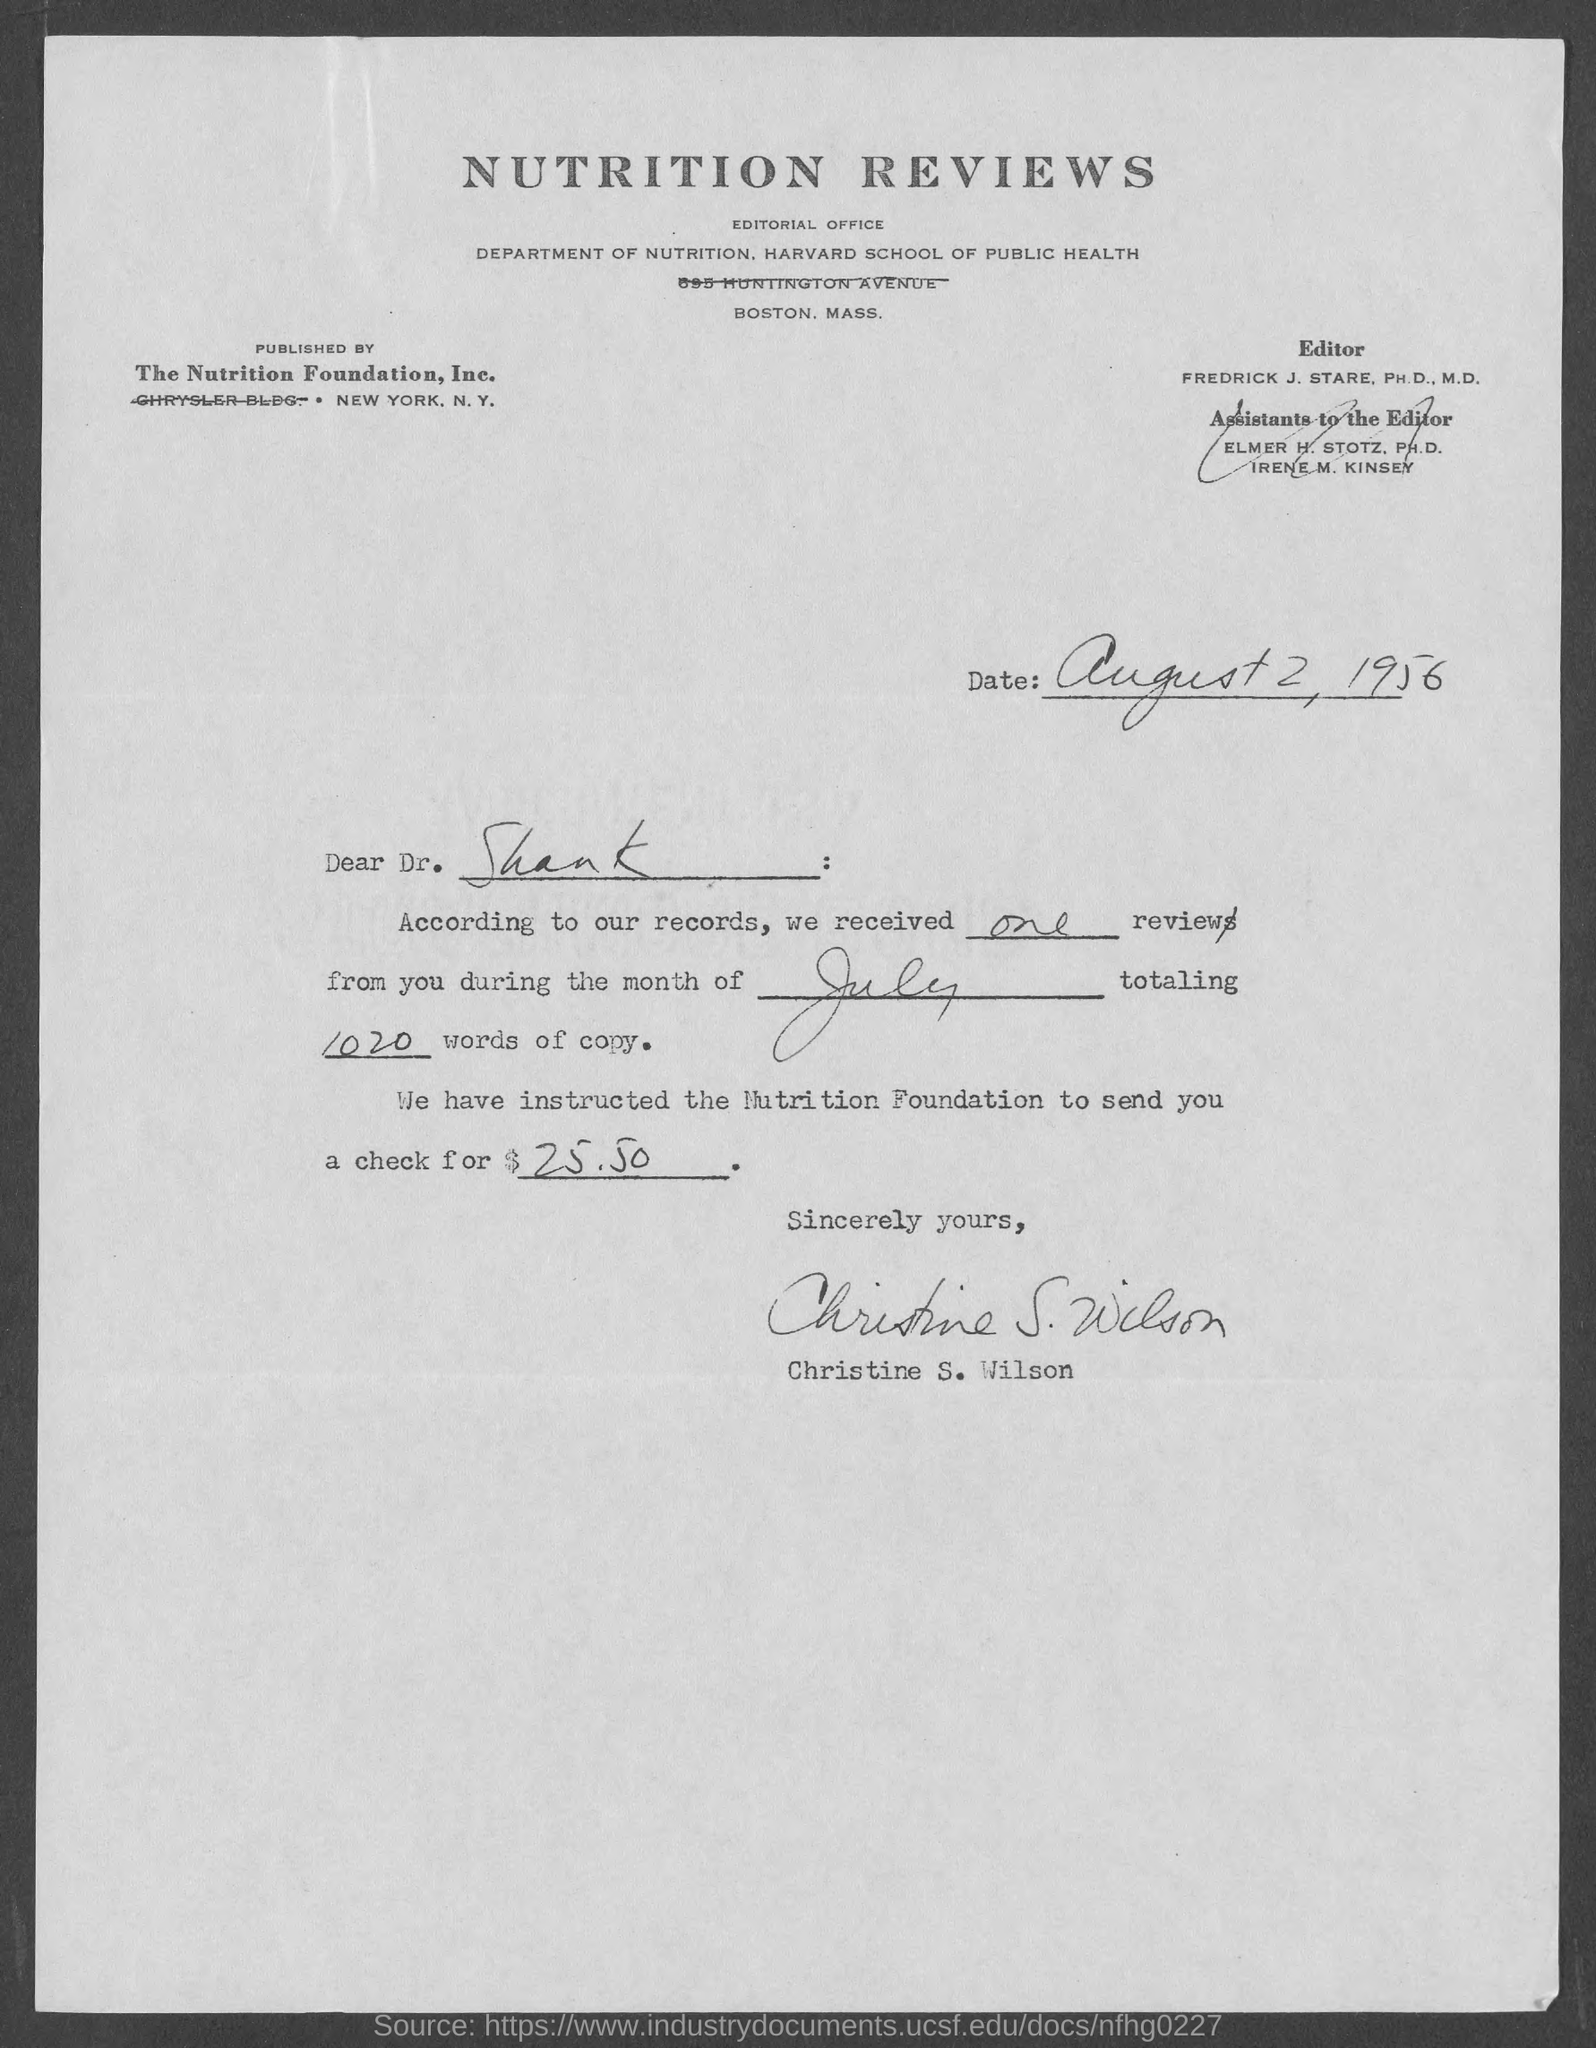Draw attention to some important aspects in this diagram. The date mentioned is August 2, 1956. The total number of words in the copy is 1020. This letter is written by Christine S. Wilson. It has been instructed that a check from the nutrition foundation be sent to you for the amount of $25.50. The subject of the sentence is "to whom this letter is sent." The predicate of the sentence is "Dr. Shank. 